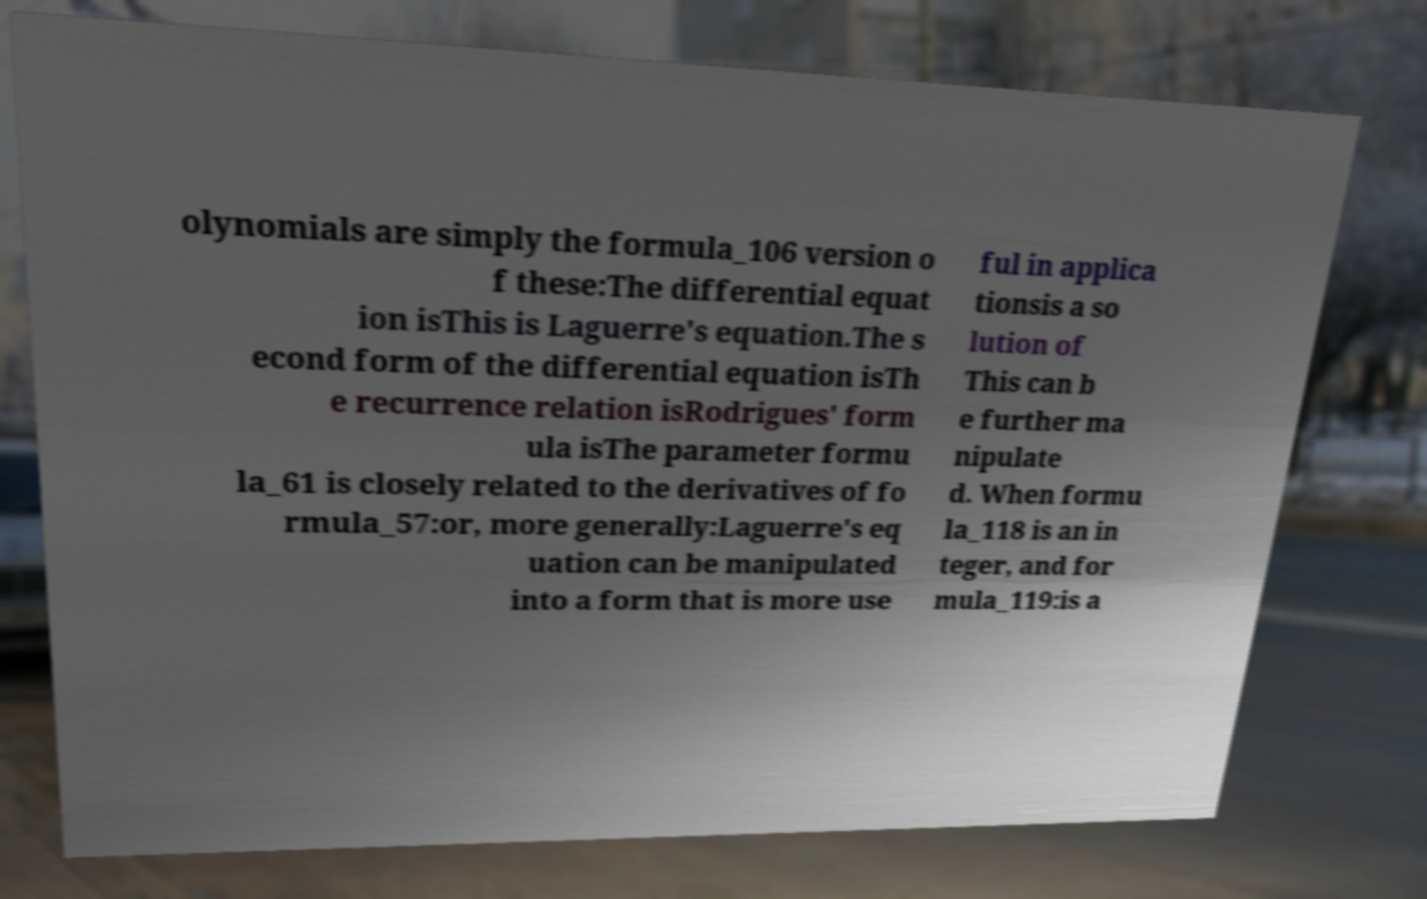For documentation purposes, I need the text within this image transcribed. Could you provide that? olynomials are simply the formula_106 version o f these:The differential equat ion isThis is Laguerre's equation.The s econd form of the differential equation isTh e recurrence relation isRodrigues' form ula isThe parameter formu la_61 is closely related to the derivatives of fo rmula_57:or, more generally:Laguerre's eq uation can be manipulated into a form that is more use ful in applica tionsis a so lution of This can b e further ma nipulate d. When formu la_118 is an in teger, and for mula_119:is a 